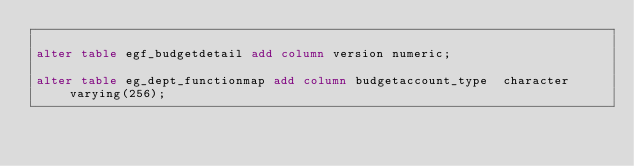<code> <loc_0><loc_0><loc_500><loc_500><_SQL_>
alter table egf_budgetdetail add column version numeric;

alter table eg_dept_functionmap add column budgetaccount_type  character varying(256);</code> 